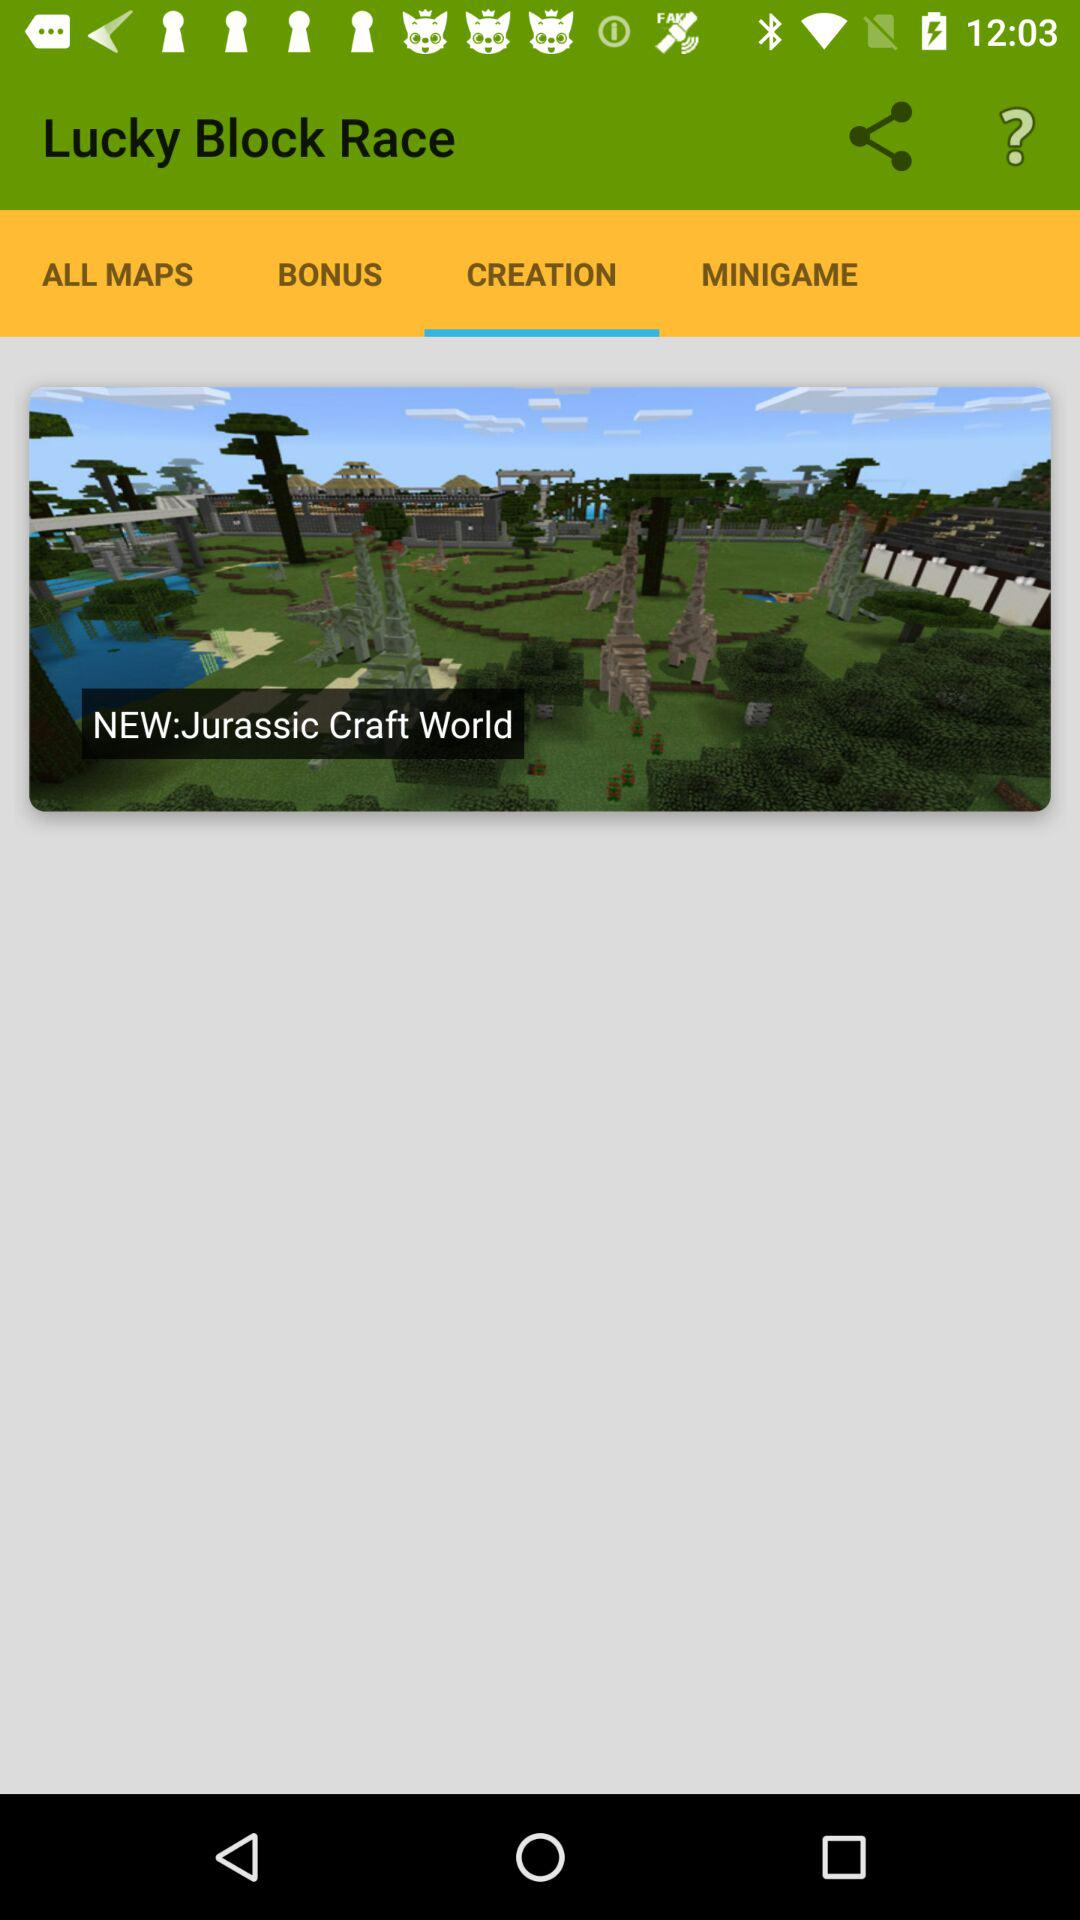Which tab is selected? The selected tab is "CREATION". 